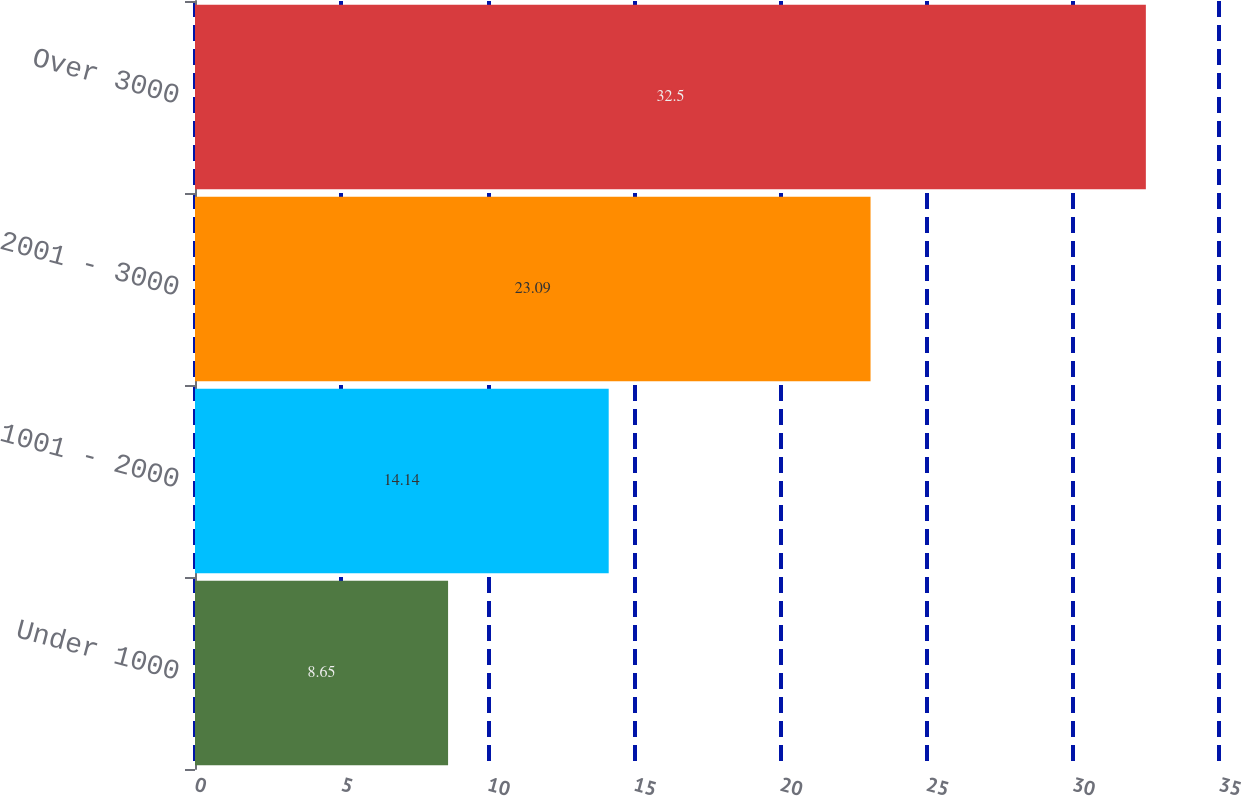Convert chart to OTSL. <chart><loc_0><loc_0><loc_500><loc_500><bar_chart><fcel>Under 1000<fcel>1001 - 2000<fcel>2001 - 3000<fcel>Over 3000<nl><fcel>8.65<fcel>14.14<fcel>23.09<fcel>32.5<nl></chart> 